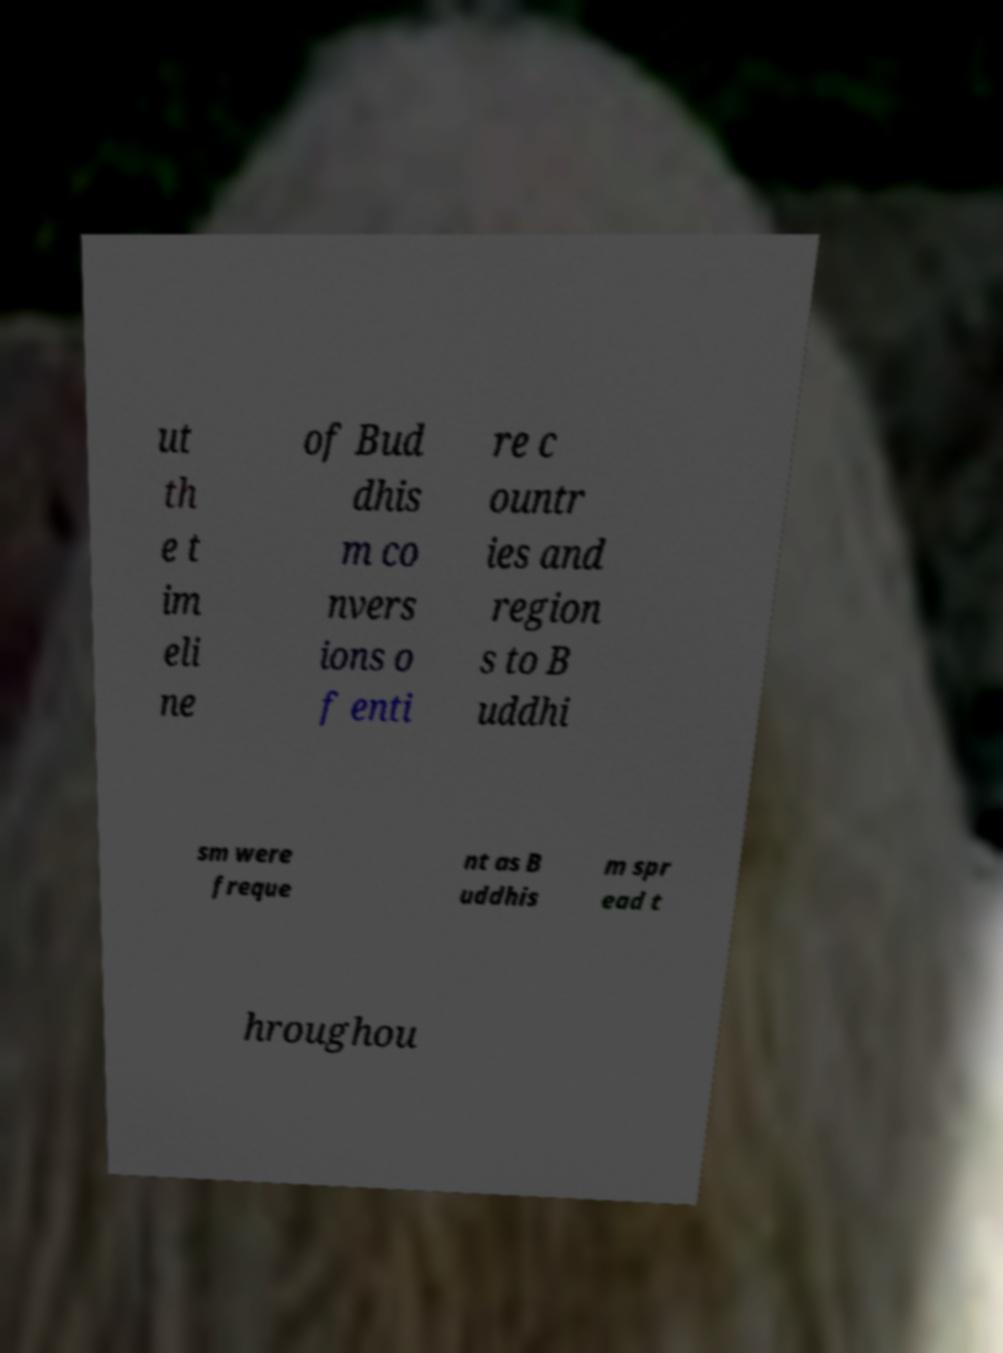Can you read and provide the text displayed in the image?This photo seems to have some interesting text. Can you extract and type it out for me? ut th e t im eli ne of Bud dhis m co nvers ions o f enti re c ountr ies and region s to B uddhi sm were freque nt as B uddhis m spr ead t hroughou 